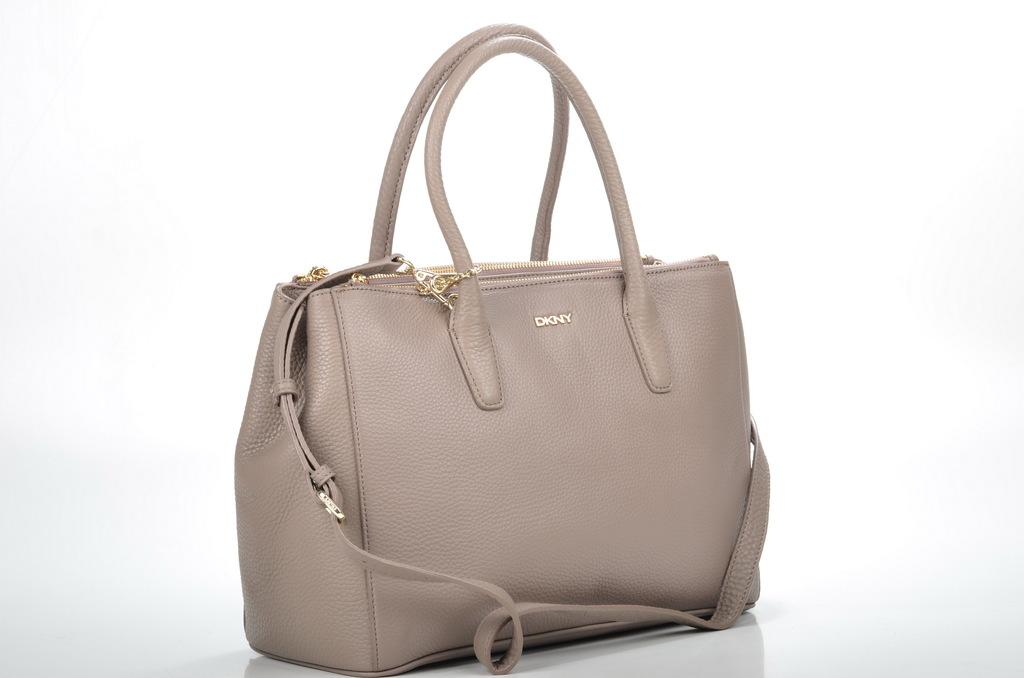What object is present in the image? There is a bag in the image. Can you describe the color of the bag? The bag is cream-colored. What can be seen in the background of the image? There is a white-colored wall in the background of the image. What type of battle is taking place in the image? There is no battle present in the image; it features a bag and a white-colored wall in the background. Can you describe the crack in the bag? There is no crack in the bag; it is described as cream-colored and whole in the image. 